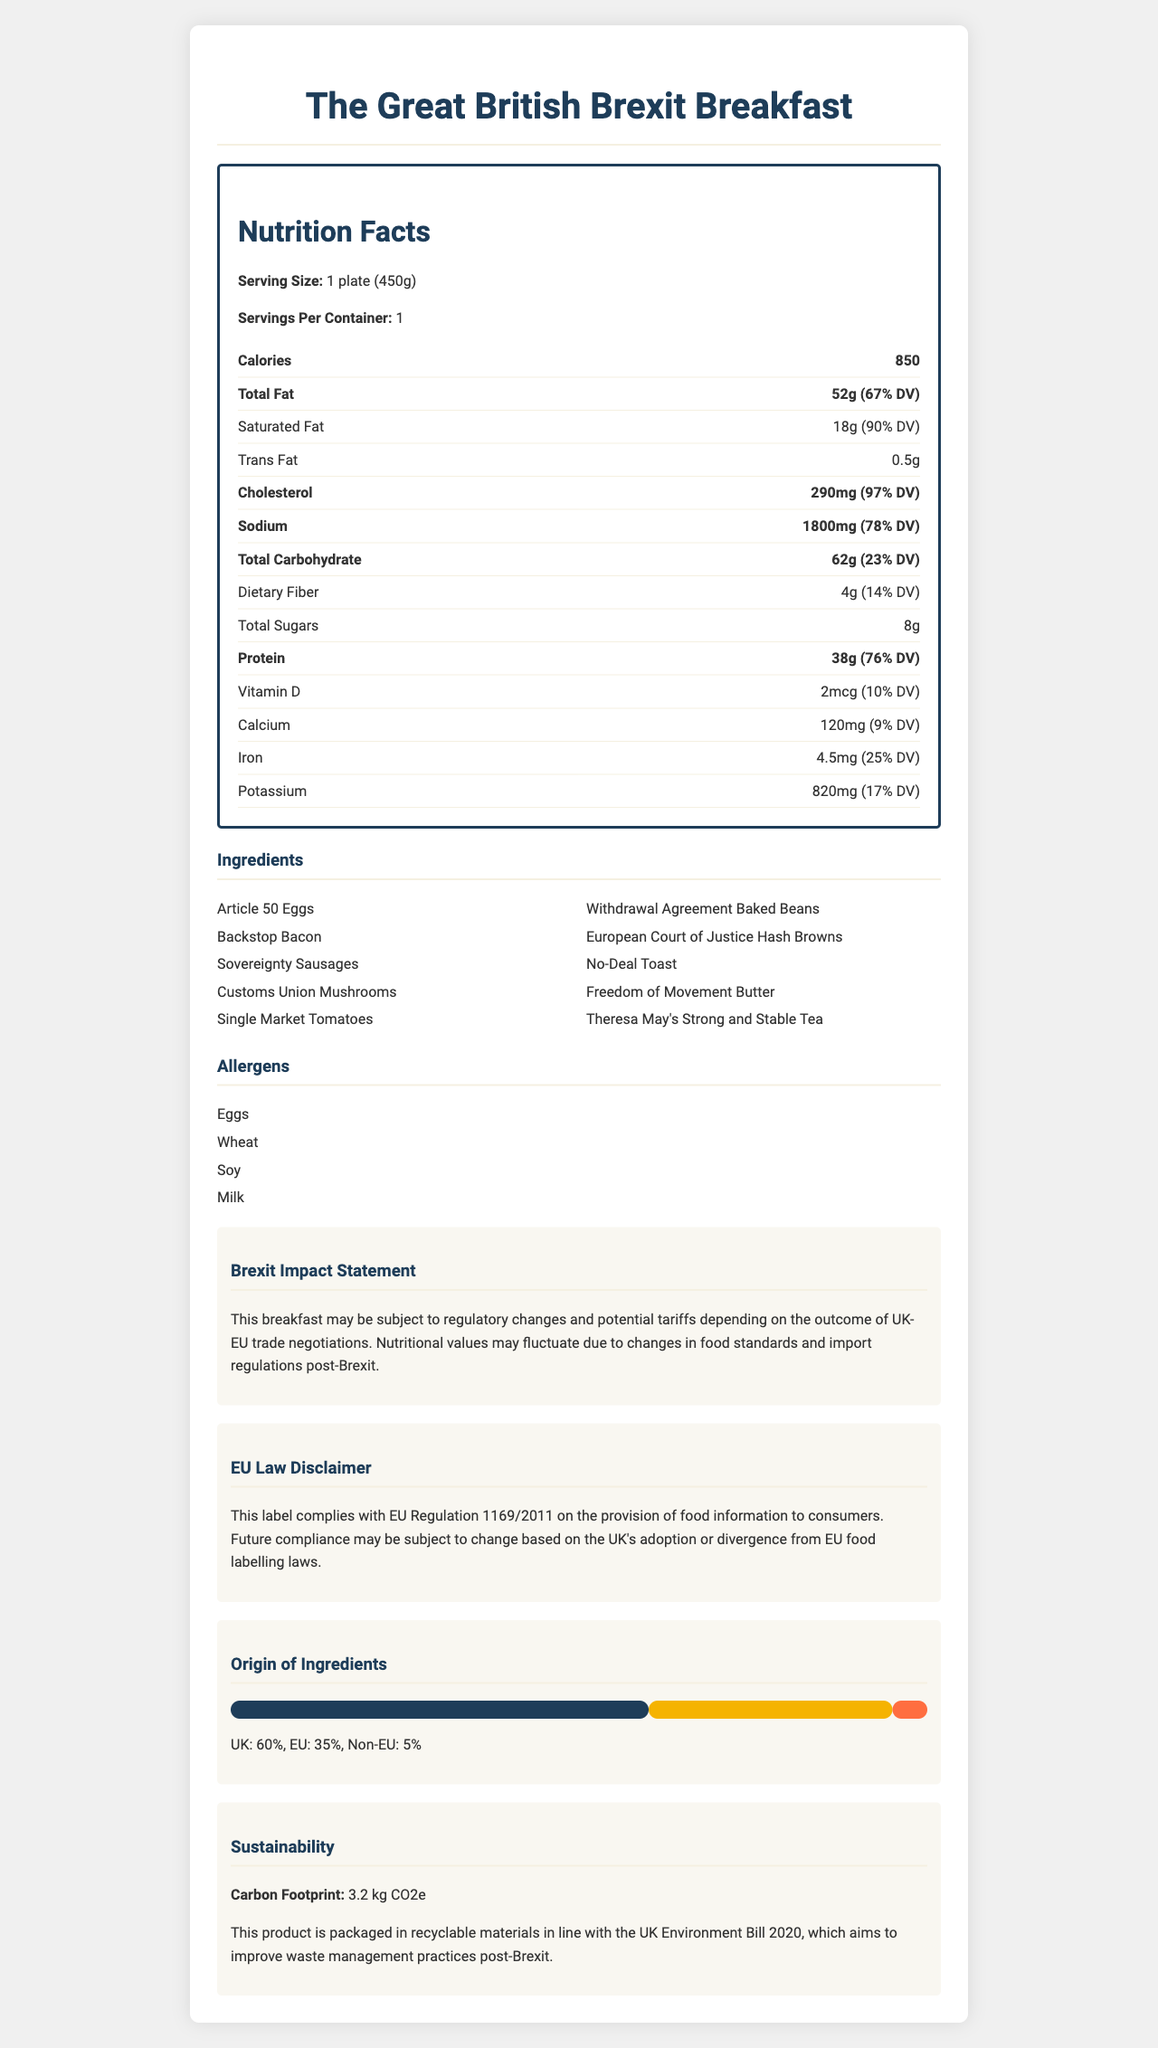what is the name of the product? The product name is clearly stated at the beginning of the document.
Answer: The Great British Brexit Breakfast what is the serving size of this breakfast? The serving size is listed under the Nutrition Facts section.
Answer: 1 plate (450g) how many calories are in one serving? The calorie count is found within the Nutrition Facts section.
Answer: 850 which ingredient has the highest fat content? A. Backstop Bacon B. Freedom of Movement Butter C. Theresa May's Strong and Stable Tea D. Sovereignty Sausages Butter typically has a higher fat content compared to other breakfast items like bacon, sausages, or tea.
Answer: B. Freedom of Movement Butter what percentage of the daily value is provided by the protein in this breakfast? The Protein section in the Nutrition Facts shows 38g which corresponds to 76% of the daily value.
Answer: 76% is there any trans fat in this breakfast? The Nutrition Facts section lists 0.5g of trans fat.
Answer: Yes what ingredients are listed as allergens in this product? The allergens are listed under the Allergens section.
Answer: Eggs, Wheat, Soy, Milk what is the brexit impact statement about this breakfast? The Brexit Impact Statement provides this information.
Answer: This breakfast may be subject to regulatory changes and potential tariffs depending on the outcome of UK-EU trade negotiations. Nutritional values may fluctuate due to changes in food standards and import regulations post-Brexit. what regulation does this label comply with according to the EU law disclaimer? A. EU Regulation 1169/2011 B. EU Regulation 1234/5678 C. UK Food Labelling Laws D. UK Environment Bill 2020 The EU law disclaimer states that the label complies with EU Regulation 1169/2011.
Answer: A. EU Regulation 1169/2011 what are the origins of the ingredients and their respective percentages? The Origin of Ingredients section provides these percentages.
Answer: UK: 60%, EU: 35%, Non-EU: 5% what is the carbon footprint of this product? The carbon footprint information is specified under the Sustainability section.
Answer: 3.2 kg CO2e what kind of packaging is used for this product? The sustainability section states that the product is packaged in recyclable materials in line with the UK Environment Bill 2020.
Answer: Recyclable materials describe the main idea of this document. The document gives a comprehensive overview of the nutritional value, components, and regulatory compliance of the product in the context of Brexit.
Answer: The document provides detailed nutritional information for The Great British Brexit Breakfast, including serving size, calorie count, fat content, and other nutrients. It also includes a list of ingredients with Brexit-themed names, allergens, a Brexit impact statement, a compliance disclaimer with EU Regulation 1169/2011, the origin of ingredients, and sustainability information regarding the packaging and carbon footprint. how many grams of dietary fiber does this breakfast contain? The dietary fiber content is listed under the Nutrition Facts section.
Answer: 4g what ingredients make up this breakfast? The list of ingredients is provided under the Ingredients section.
Answer: Article 50 Eggs, Backstop Bacon, Sovereignty Sausages, Customs Union Mushrooms, Single Market Tomatoes, Withdrawal Agreement Baked Beans, European Court of Justice Hash Browns, No-Deal Toast, Freedom of Movement Butter, Theresa May's Strong and Stable Tea is there suffficient information to estimate the greenhouse gas emissions from logistics of the breakfast? The document only provides the carbon footprint in kg CO2e but does not detail the logistics or emissions from transportation.
Answer: Not enough information how much iron does this breakfast provide? The iron content and its daily value percentage are listed in the Nutrition Facts section.
Answer: 4.5mg (25% DV) 